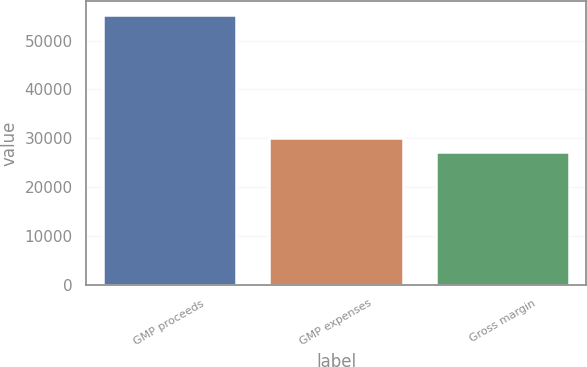Convert chart. <chart><loc_0><loc_0><loc_500><loc_500><bar_chart><fcel>GMP proceeds<fcel>GMP expenses<fcel>Gross margin<nl><fcel>55261<fcel>30000.7<fcel>27194<nl></chart> 